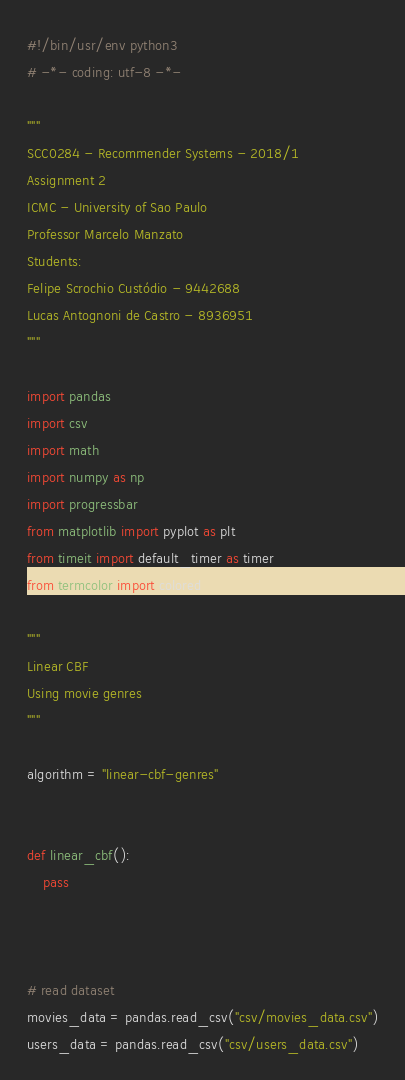<code> <loc_0><loc_0><loc_500><loc_500><_Python_>#!/bin/usr/env python3
# -*- coding: utf-8 -*-

"""
SCC0284 - Recommender Systems - 2018/1
Assignment 2
ICMC - University of Sao Paulo
Professor Marcelo Manzato
Students:
Felipe Scrochio Custódio - 9442688
Lucas Antognoni de Castro - 8936951
"""

import pandas
import csv
import math
import numpy as np
import progressbar
from matplotlib import pyplot as plt
from timeit import default_timer as timer
from termcolor import colored

"""
Linear CBF
Using movie genres
"""

algorithm = "linear-cbf-genres"


def linear_cbf():
    pass



# read dataset
movies_data = pandas.read_csv("csv/movies_data.csv")
users_data = pandas.read_csv("csv/users_data.csv")</code> 